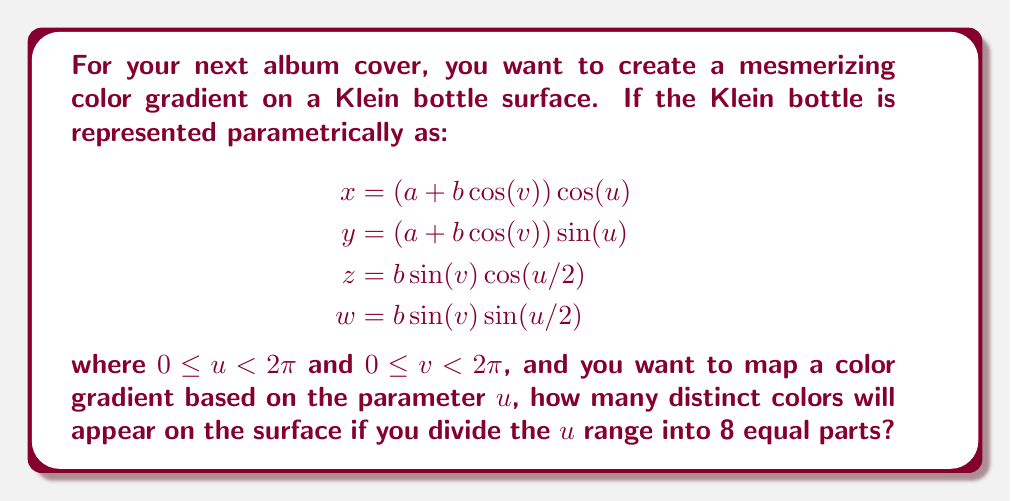Can you answer this question? Let's approach this step-by-step:

1) First, we need to understand the properties of a Klein bottle:
   - It's a non-orientable surface
   - It has no inside or outside
   - It can't be embedded in 3D space without intersecting itself

2) The parametric equation given represents the Klein bottle in 4D space, where:
   - $u$ and $v$ are the parameters
   - $a$ and $b$ are constants determining the size and shape

3) We're focusing on the parameter $u$, which has a range of $0 \leq u < 2\pi$

4) The question asks to divide this range into 8 equal parts. This means we're creating 8 intervals:
   $$[0, \frac{\pi}{4}), [\frac{\pi}{4}, \frac{\pi}{2}), [\frac{\pi}{2}, \frac{3\pi}{4}), ..., [\frac{7\pi}{4}, 2\pi)$$

5) Normally, this would result in 8 distinct colors. However, we need to consider the unique properties of the Klein bottle.

6) In the parametric equations, $u$ appears in two forms:
   - As $u$ in $\cos(u)$ and $\sin(u)$
   - As $u/2$ in $\cos(u/2)$ and $\sin(u/2)$

7) The terms with $u$ have a period of $2\pi$, while the terms with $u/2$ have a period of $4\pi$

8) This means that as $u$ goes from $0$ to $2\pi$, the surface doesn't exactly return to its starting point in 4D space.

9) However, the color gradient is based solely on $u$, not on the 4D coordinates.

10) Therefore, despite the complex geometry of the Klein bottle, the color gradient will simply follow the division of $u$ into 8 parts.

Thus, there will be 8 distinct colors appearing on the surface of the Klein bottle.
Answer: 8 distinct colors 